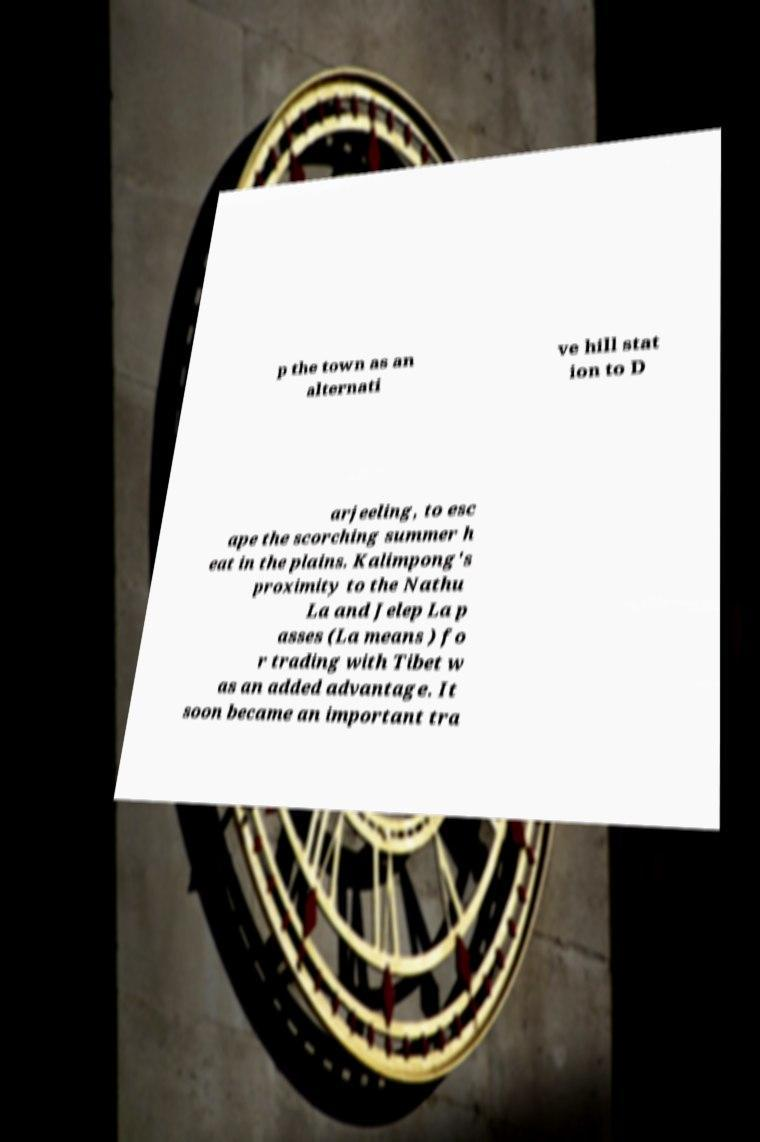There's text embedded in this image that I need extracted. Can you transcribe it verbatim? p the town as an alternati ve hill stat ion to D arjeeling, to esc ape the scorching summer h eat in the plains. Kalimpong's proximity to the Nathu La and Jelep La p asses (La means ) fo r trading with Tibet w as an added advantage. It soon became an important tra 